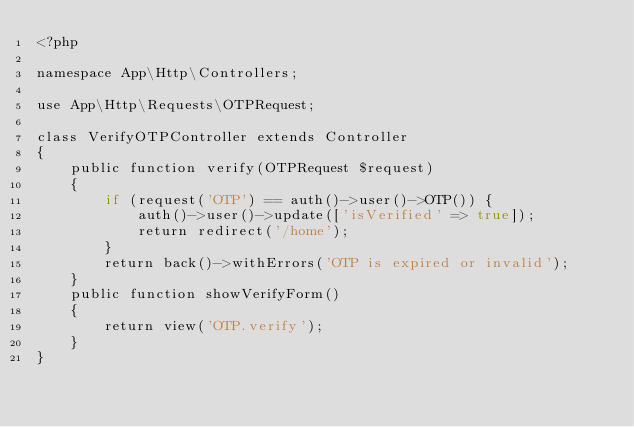Convert code to text. <code><loc_0><loc_0><loc_500><loc_500><_PHP_><?php

namespace App\Http\Controllers;

use App\Http\Requests\OTPRequest;

class VerifyOTPController extends Controller
{
    public function verify(OTPRequest $request)
    {
        if (request('OTP') == auth()->user()->OTP()) {
            auth()->user()->update(['isVerified' => true]);
            return redirect('/home');
        }
        return back()->withErrors('OTP is expired or invalid');
    }
    public function showVerifyForm()
    {
        return view('OTP.verify');
    }
}
</code> 